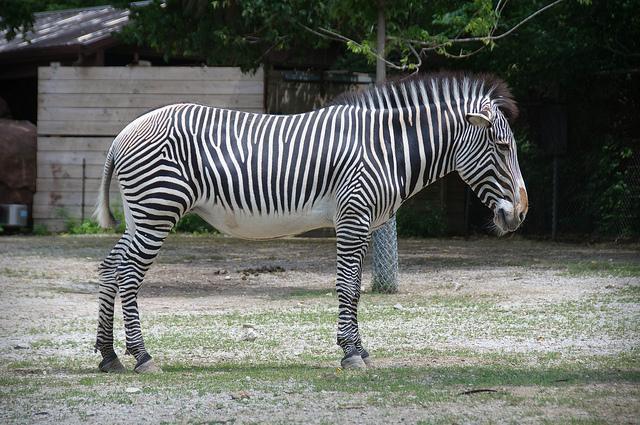How many zebras are there?
Give a very brief answer. 1. How many people are sitting around the table?
Give a very brief answer. 0. 